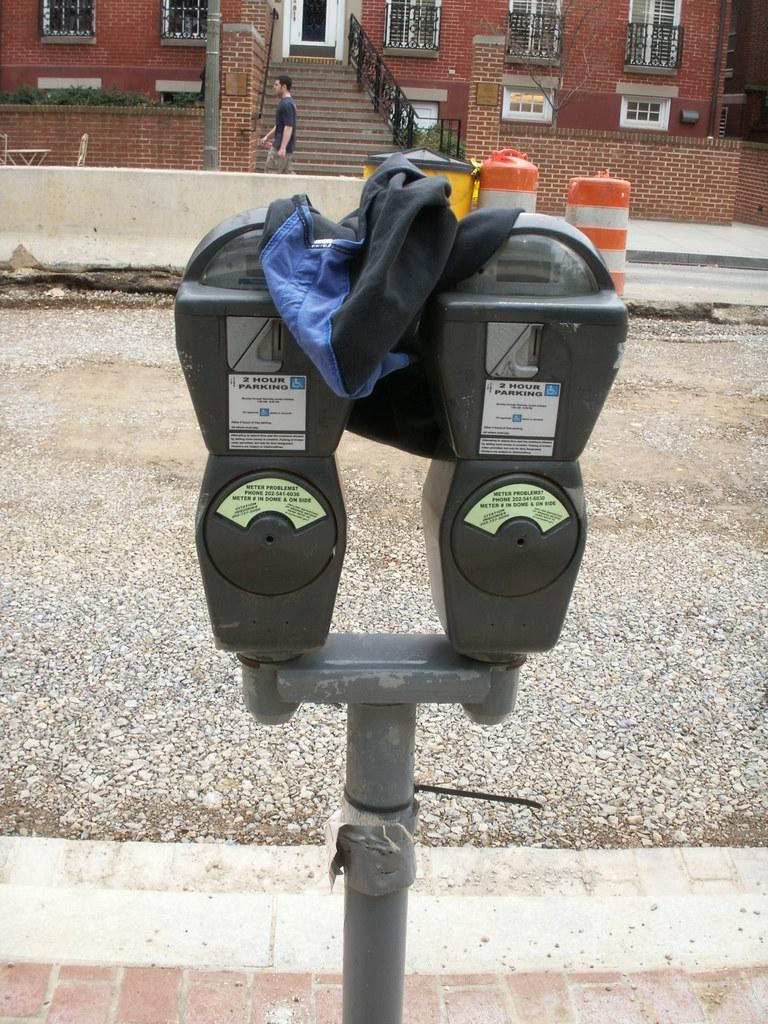Provide a one-sentence caption for the provided image. The longest one can park on this street is two hours. 